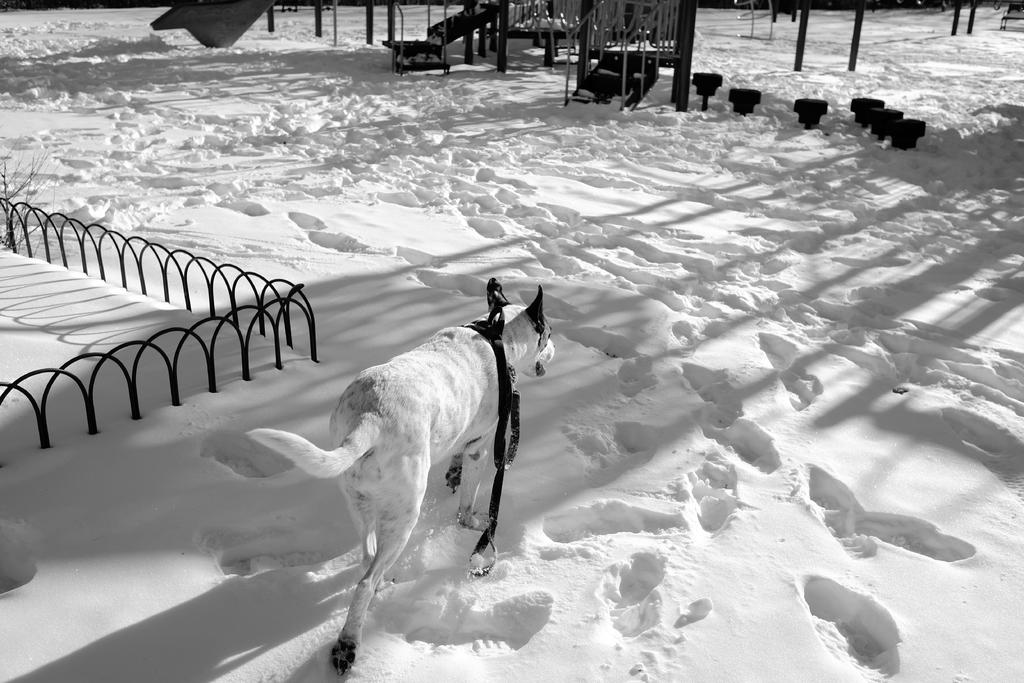What animal can be seen in the image? There is a dog in the image. What is the dog doing in the image? The dog is walking in the snow. Is there anything attached to the dog's neck? Yes, the dog has a string around its neck. What is the color of the dog in the image? The dog is white in color. What else can be seen in the image besides the dog? There are poles visible in the image. What type of cabbage is the dog eating in the image? There is no cabbage present in the image, and the dog is not eating anything. Can you describe the desk that the dog is sitting on in the image? There is no desk present in the image; the dog is walking in the snow. 